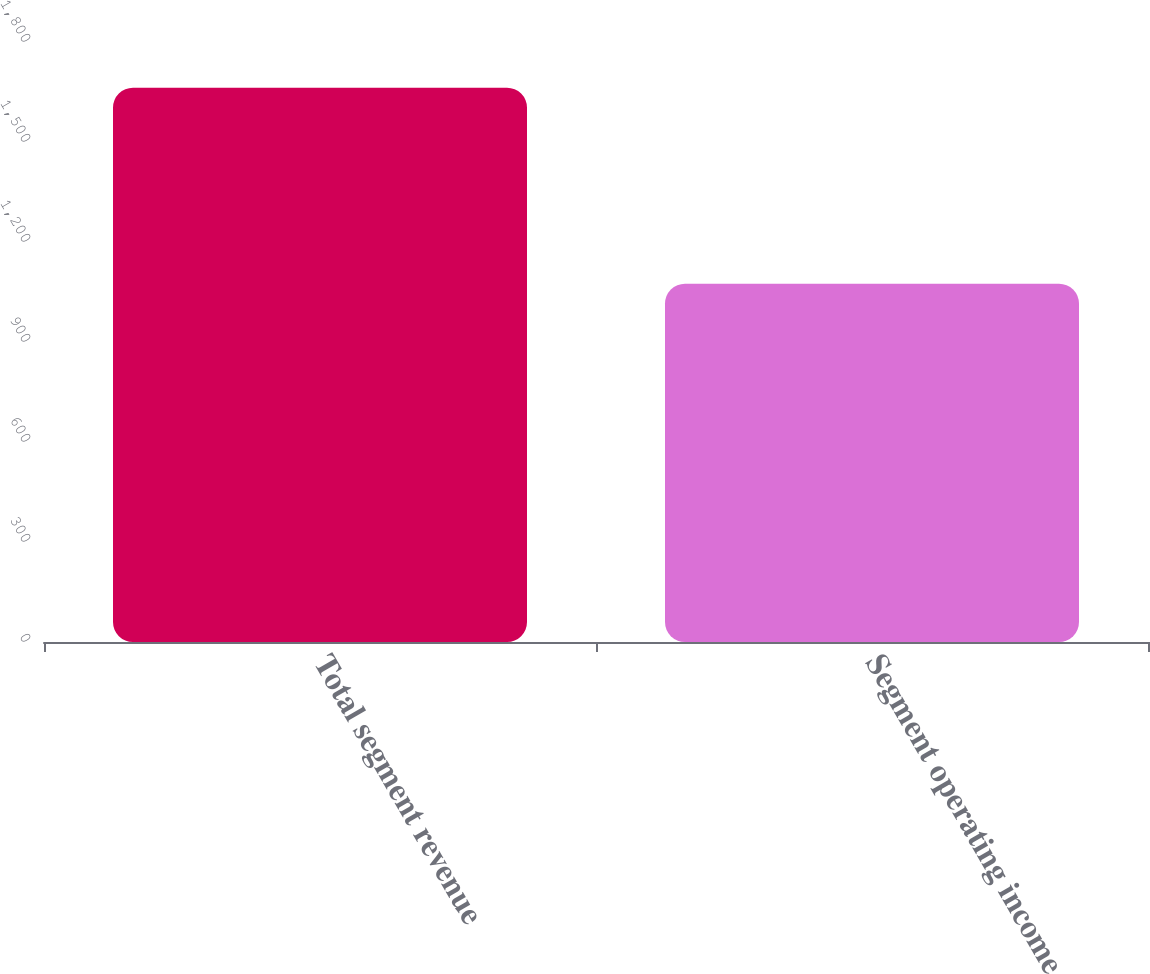Convert chart. <chart><loc_0><loc_0><loc_500><loc_500><bar_chart><fcel>Total segment revenue<fcel>Segment operating income<nl><fcel>1663<fcel>1075<nl></chart> 